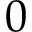Convert formula to latex. <formula><loc_0><loc_0><loc_500><loc_500>0</formula> 